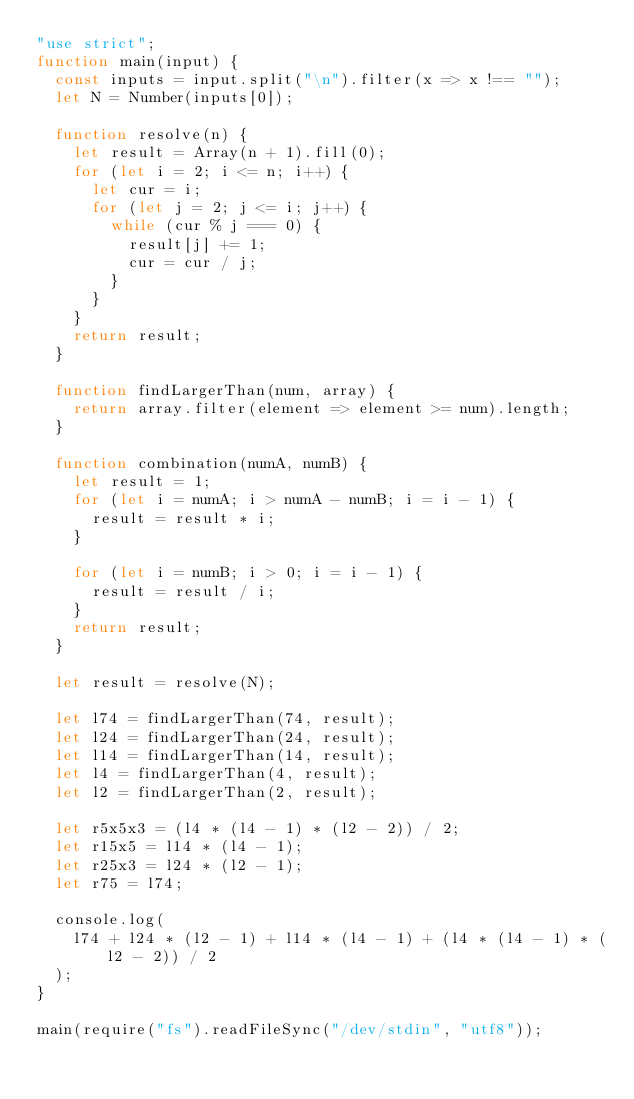<code> <loc_0><loc_0><loc_500><loc_500><_JavaScript_>"use strict";
function main(input) {
  const inputs = input.split("\n").filter(x => x !== "");
  let N = Number(inputs[0]);

  function resolve(n) {
    let result = Array(n + 1).fill(0);
    for (let i = 2; i <= n; i++) {
      let cur = i;
      for (let j = 2; j <= i; j++) {
        while (cur % j === 0) {
          result[j] += 1;
          cur = cur / j;
        }
      }
    }
    return result;
  }

  function findLargerThan(num, array) {
    return array.filter(element => element >= num).length;
  }

  function combination(numA, numB) {
    let result = 1;
    for (let i = numA; i > numA - numB; i = i - 1) {
      result = result * i;
    }

    for (let i = numB; i > 0; i = i - 1) {
      result = result / i;
    }
    return result;
  }

  let result = resolve(N);

  let l74 = findLargerThan(74, result);
  let l24 = findLargerThan(24, result);
  let l14 = findLargerThan(14, result);
  let l4 = findLargerThan(4, result);
  let l2 = findLargerThan(2, result);

  let r5x5x3 = (l4 * (l4 - 1) * (l2 - 2)) / 2;
  let r15x5 = l14 * (l4 - 1);
  let r25x3 = l24 * (l2 - 1);
  let r75 = l74;

  console.log(
    l74 + l24 * (l2 - 1) + l14 * (l4 - 1) + (l4 * (l4 - 1) * (l2 - 2)) / 2
  );
}

main(require("fs").readFileSync("/dev/stdin", "utf8"));
</code> 